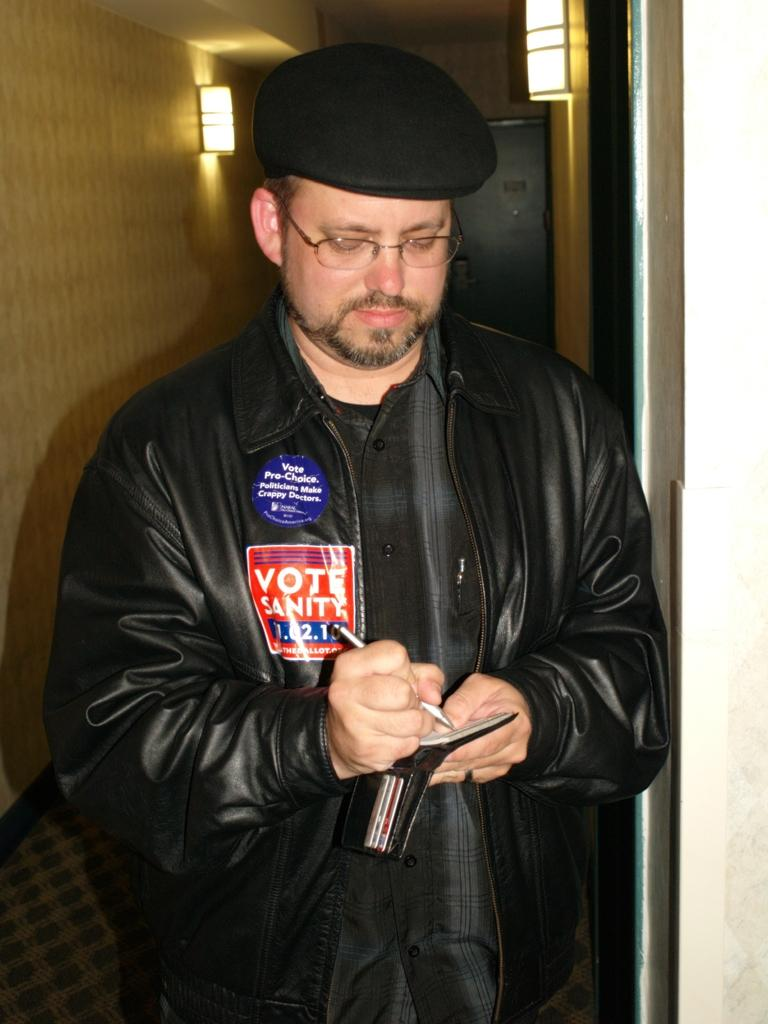What is happening in the image involving a person? There is a person in the image who is writing on an object. Can you describe the object the person is writing on? Unfortunately, the specific object cannot be determined from the provided facts. What is located behind the person in the image? There is an object behind the person in the image. How many lamps are visible in the image? There are two lamps in the image. Are there any cherries visible in the image? There is no mention of cherries in the provided facts, so we cannot determine if they are present in the image. What types of pets can be seen in the image? There is no mention of pets in the provided facts, so we cannot determine if they are present in the image. 